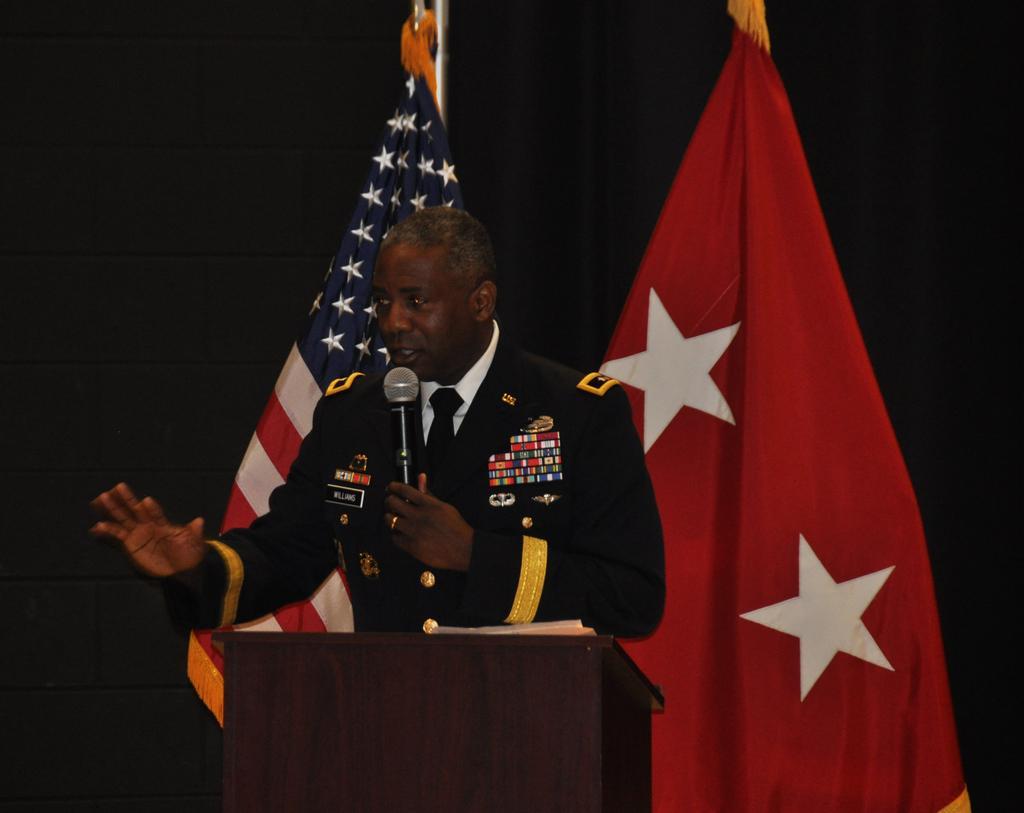Could you give a brief overview of what you see in this image? In the image we can see a man standing, wearing clothes, finger ring and holding a microphone in his hand. Here we can see the podium and behind the man we can see the two different flags. The background is dark. 